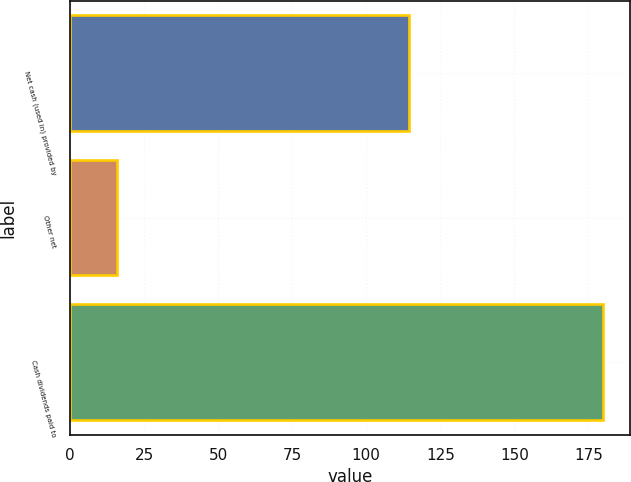Convert chart. <chart><loc_0><loc_0><loc_500><loc_500><bar_chart><fcel>Net cash (used in) provided by<fcel>Other net<fcel>Cash dividends paid to<nl><fcel>114.4<fcel>16<fcel>180<nl></chart> 